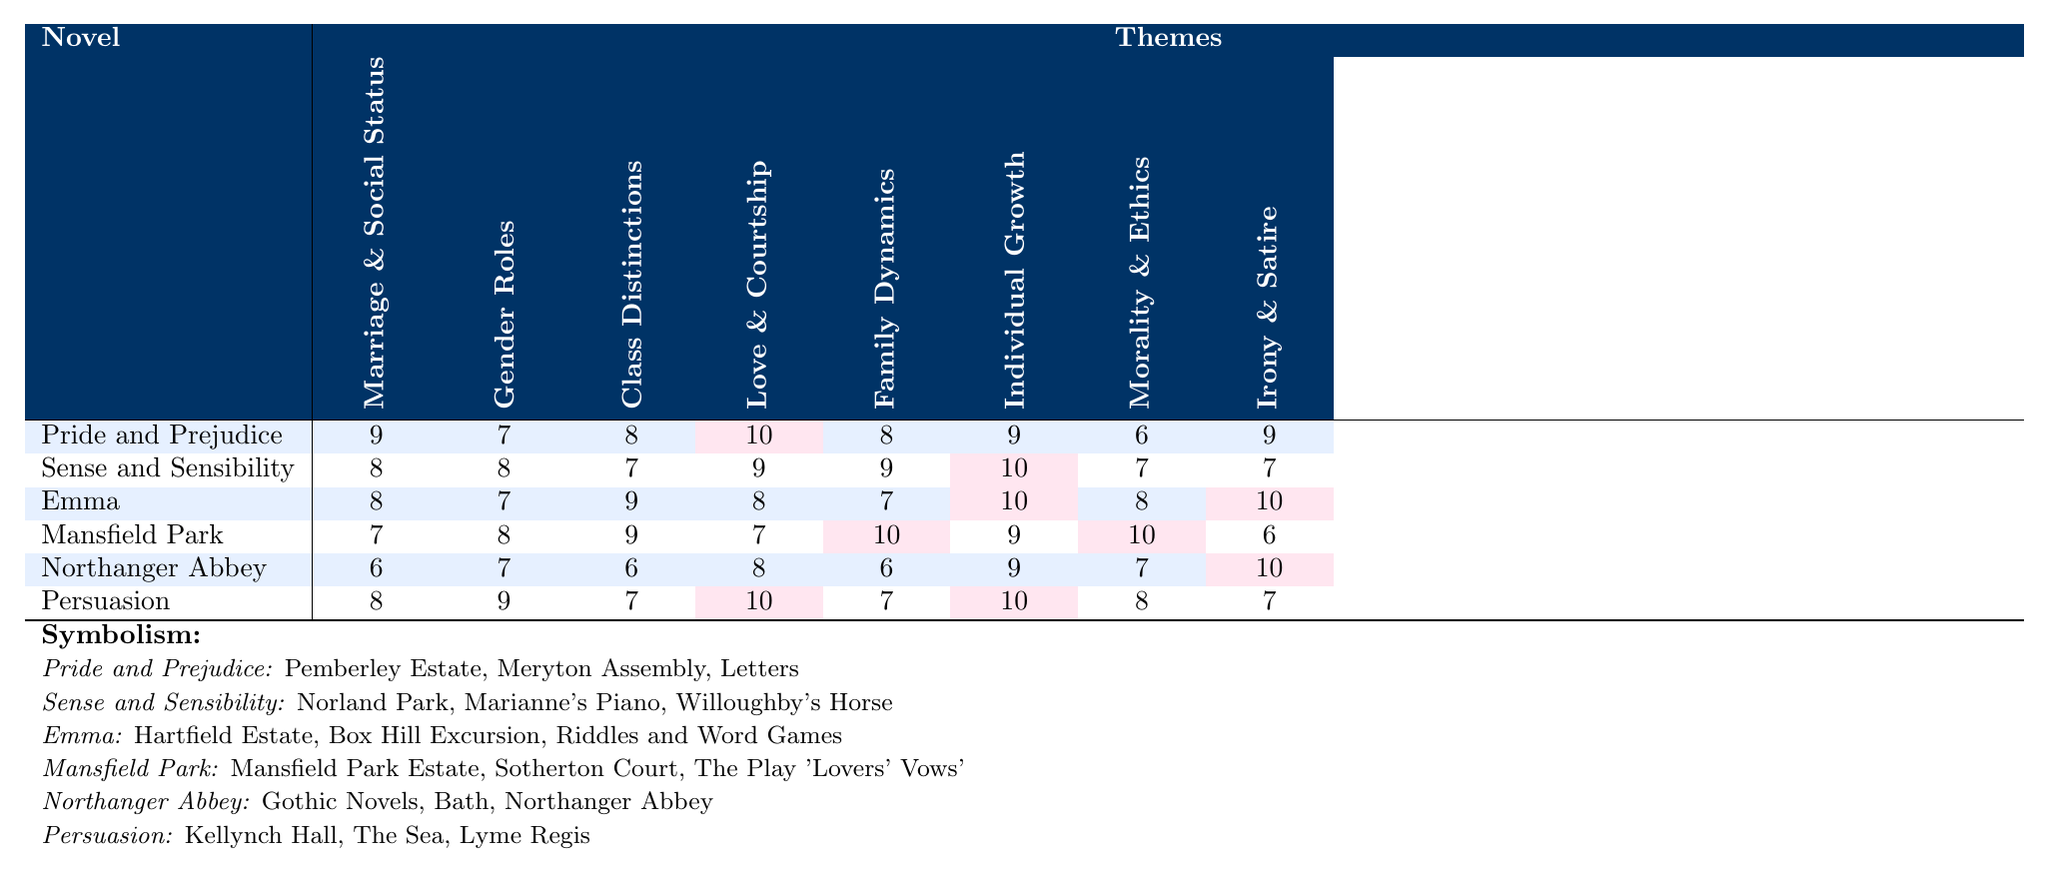What novel has the highest score for Love and Courtship? The scores for Love and Courtship are as follows: Pride and Prejudice (10), Sense and Sensibility (9), Emma (8), Mansfield Park (7), Northanger Abbey (8), and Persuasion (10). Pride and Prejudice and Persuasion both have the highest score of 10.
Answer: Pride and Prejudice and Persuasion Which themes are prominent in Mansfield Park? The scores for Mansfield Park are: Marriage and Social Status (7), Gender Roles (8), Class Distinctions (9), Love and Courtship (7), Family Dynamics (10), Individual Growth (9), Morality and Ethics (10), Irony and Satire (6). Family Dynamics and Morality and Ethics have the highest scores of 10, indicating they are prominent themes.
Answer: Family Dynamics and Morality and Ethics True or False: Northanger Abbey has the lowest score for Marriage and Social Status. Northanger Abbey has a score of 6 for Marriage and Social Status, while Pride and Prejudice (9), Sense and Sensibility (8), Emma (8), and Mansfield Park (7) all have higher scores. Therefore, it is true that Northanger Abbey has the lowest score for this theme.
Answer: True What is the average score for Individual Growth across all novels? To find the average score for Individual Growth, sum the scores: (9 + 10 + 10 + 9 + 9 + 10) = 57. Since there are 6 novels, divide the total by 6: 57 / 6 = 9.5.
Answer: 9.5 Which novel shows the greatest improvement in Individual Growth from Northanger Abbey to Persuasion? Northanger Abbey has a score of 9 for Individual Growth, while Persuasion has a score of 10. The improvement is calculated as 10 - 9 = 1. Thus, the increase from Northanger Abbey to Persuasion represents the greatest improvement in this category.
Answer: 1 Which themes have consistently high scores (8 or above) across all novels? By reviewing the scores, only the themes of Individual Growth and Love and Courtship have scores of 8 or above in all novels. Individual Growth scores: 9, 10, 10, 9, 9, 10; Love and Courtship scores: 10, 9, 8, 7, 8, 10.
Answer: Individual Growth and Love and Courtship Is there a novel where Class Distinctions scored higher than Gender Roles? Reviewing the data: In Pride and Prejudice (Class Distinctions 8, Gender Roles 7), Sense and Sensibility (Class Distinctions 7, Gender Roles 8), Emma (Class Distinctions 9, Gender Roles 7), Mansfield Park (Class Distinctions 9, Gender Roles 8), Northanger Abbey (Class Distinctions 6, Gender Roles 7), and Persuasion (Class Distinctions 7, Gender Roles 9). The only instance where Class Distinctions scored higher is in Pride and Prejudice, indicating a yes.
Answer: Yes What are the overall themes across Jane Austen's novels based on the table? The overall themes present in the table are: Marriage and Social Status, Gender Roles, Class Distinctions, Love and Courtship, Family Dynamics, Individual Growth, Morality and Ethics, Irony and Satire. All these themes recur throughout the novels indicating the complexity of societal interactions.
Answer: Eight themes Which symbol is associated with Emma? According to the symbols listed, Emma is associated with Hartfield Estate, Box Hill Excursion, and Riddles and Word Games. Hartfield Estate is significant as it is Emma’s home.
Answer: Hartfield Estate, Box Hill Excursion, and Riddles and Word Games 